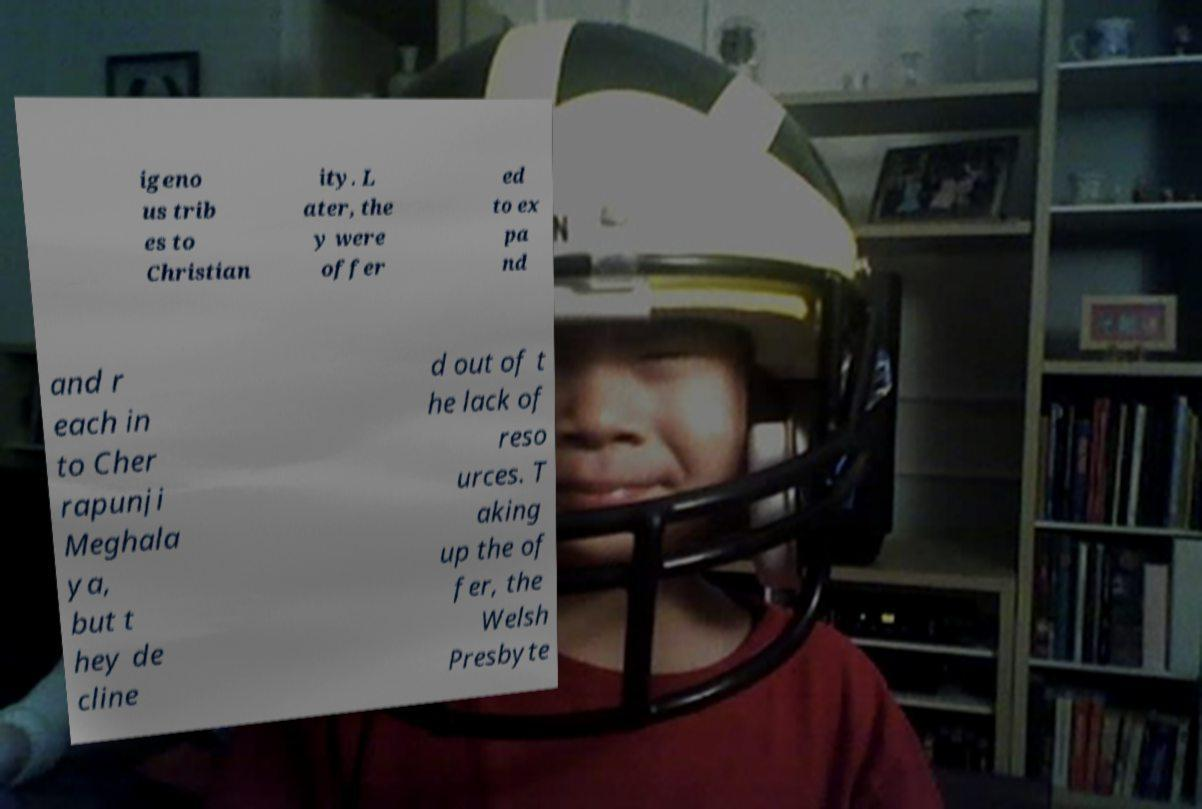Could you assist in decoding the text presented in this image and type it out clearly? igeno us trib es to Christian ity. L ater, the y were offer ed to ex pa nd and r each in to Cher rapunji Meghala ya, but t hey de cline d out of t he lack of reso urces. T aking up the of fer, the Welsh Presbyte 